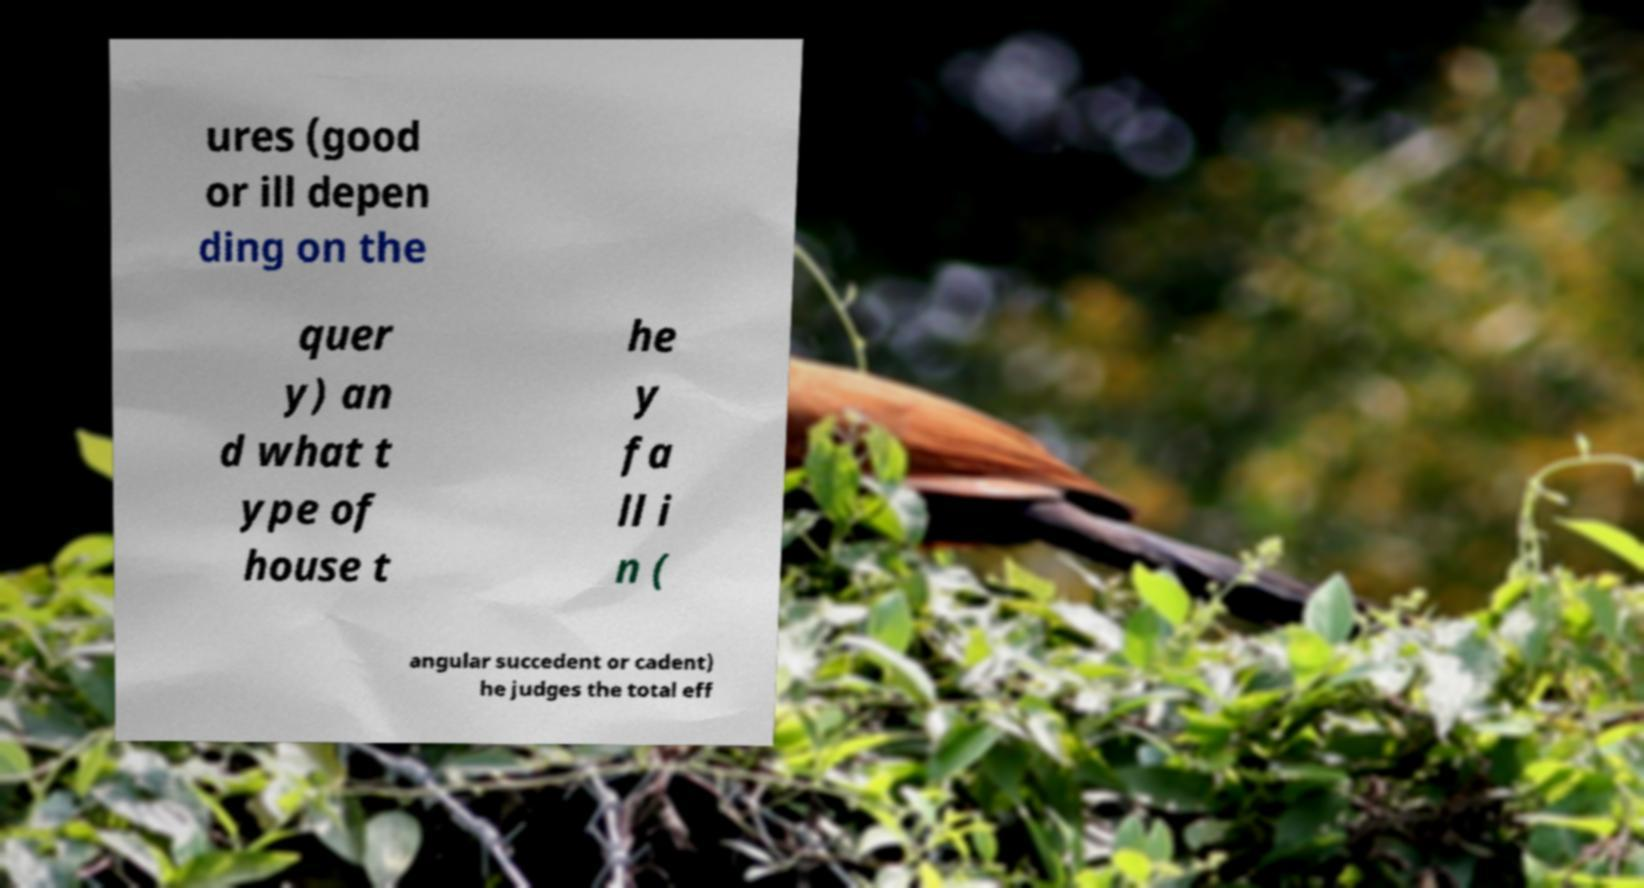For documentation purposes, I need the text within this image transcribed. Could you provide that? ures (good or ill depen ding on the quer y) an d what t ype of house t he y fa ll i n ( angular succedent or cadent) he judges the total eff 